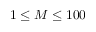<formula> <loc_0><loc_0><loc_500><loc_500>1 \leq M \leq 1 0 0</formula> 